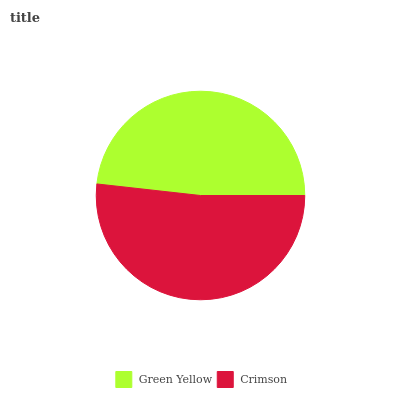Is Green Yellow the minimum?
Answer yes or no. Yes. Is Crimson the maximum?
Answer yes or no. Yes. Is Crimson the minimum?
Answer yes or no. No. Is Crimson greater than Green Yellow?
Answer yes or no. Yes. Is Green Yellow less than Crimson?
Answer yes or no. Yes. Is Green Yellow greater than Crimson?
Answer yes or no. No. Is Crimson less than Green Yellow?
Answer yes or no. No. Is Crimson the high median?
Answer yes or no. Yes. Is Green Yellow the low median?
Answer yes or no. Yes. Is Green Yellow the high median?
Answer yes or no. No. Is Crimson the low median?
Answer yes or no. No. 